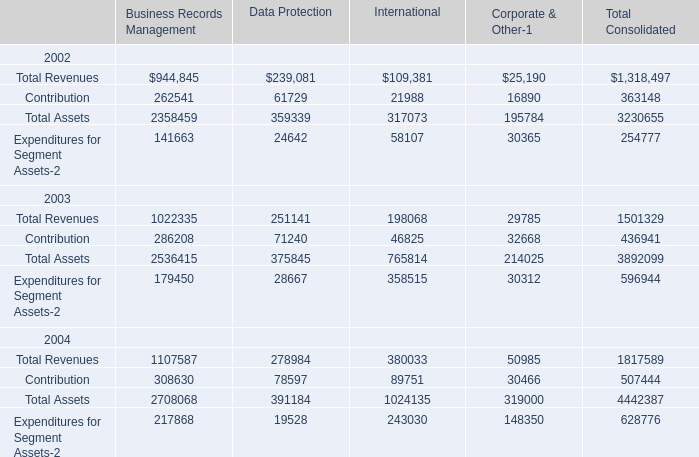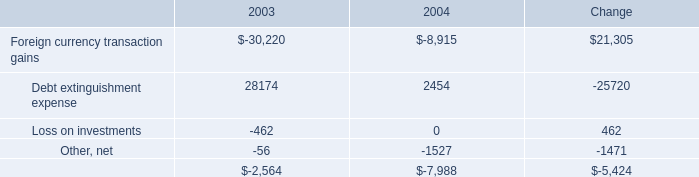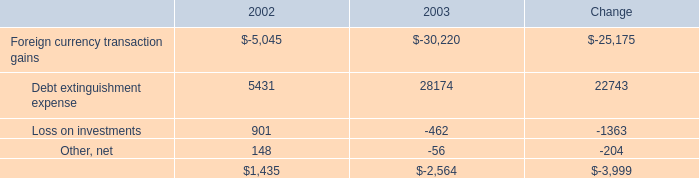What's the sum of Contribution 2003 of Business Records Management, Foreign currency transaction gains of Change, and Contribution 2004 of International ? 
Computations: ((286208.0 + 21305.0) + 89751.0)
Answer: 397264.0. 